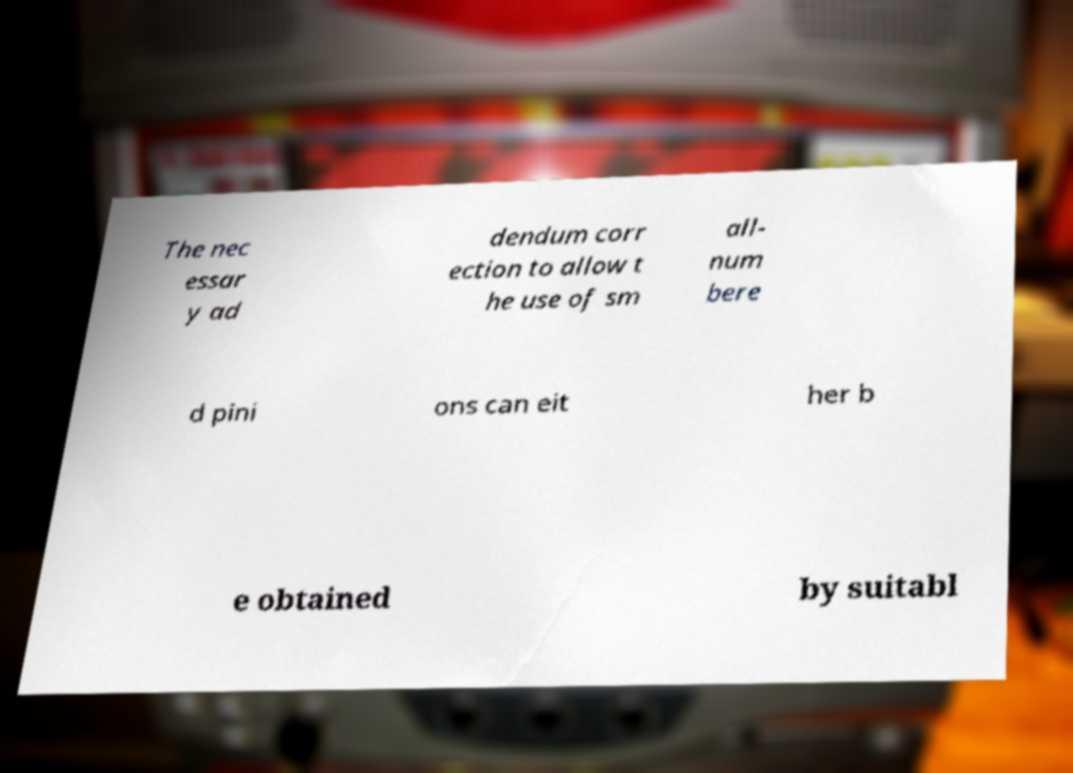Can you accurately transcribe the text from the provided image for me? The nec essar y ad dendum corr ection to allow t he use of sm all- num bere d pini ons can eit her b e obtained by suitabl 